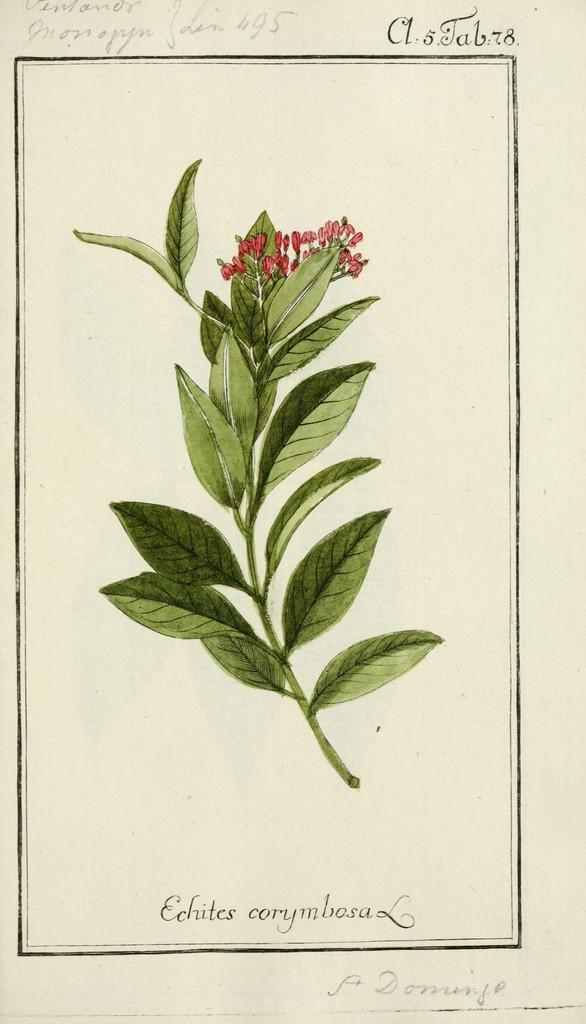Describe this image in one or two sentences. In this image we can see flowers and leaves on a stem. 